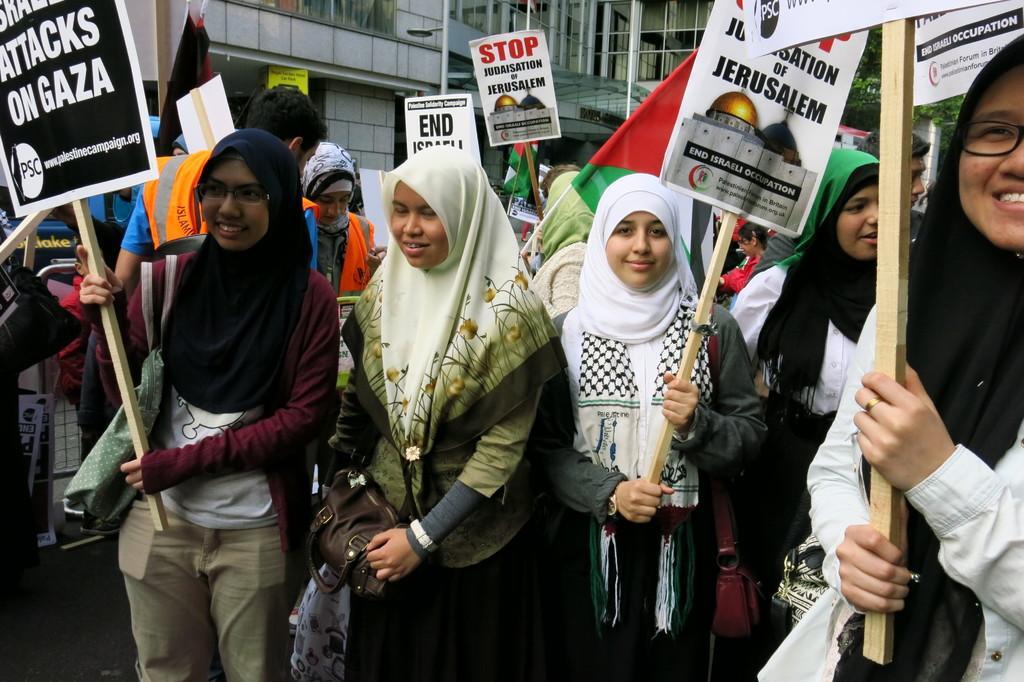Could you give a brief overview of what you see in this image? In this image we can see women standing on the road and holding placards in their hands. In the background we can see buildings. 